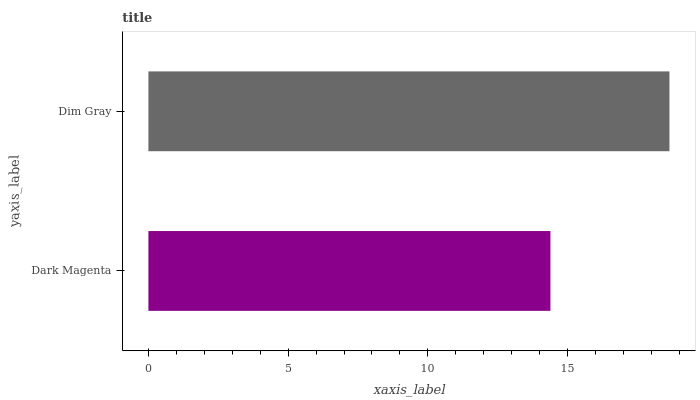Is Dark Magenta the minimum?
Answer yes or no. Yes. Is Dim Gray the maximum?
Answer yes or no. Yes. Is Dim Gray the minimum?
Answer yes or no. No. Is Dim Gray greater than Dark Magenta?
Answer yes or no. Yes. Is Dark Magenta less than Dim Gray?
Answer yes or no. Yes. Is Dark Magenta greater than Dim Gray?
Answer yes or no. No. Is Dim Gray less than Dark Magenta?
Answer yes or no. No. Is Dim Gray the high median?
Answer yes or no. Yes. Is Dark Magenta the low median?
Answer yes or no. Yes. Is Dark Magenta the high median?
Answer yes or no. No. Is Dim Gray the low median?
Answer yes or no. No. 